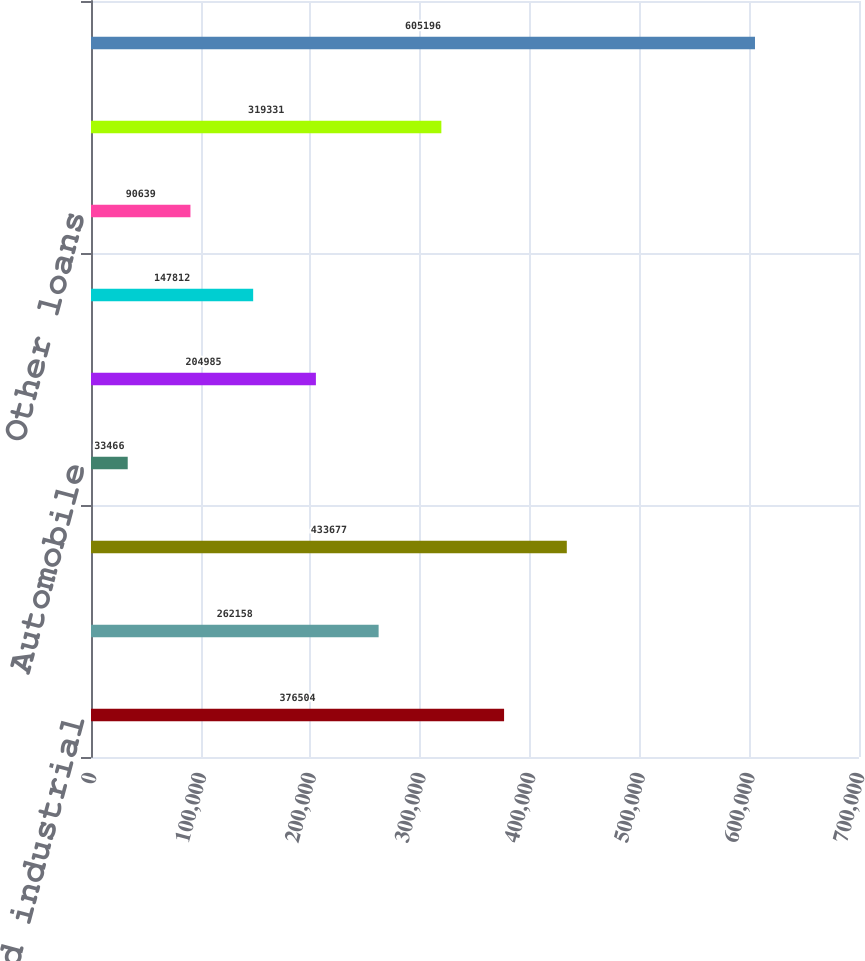Convert chart. <chart><loc_0><loc_0><loc_500><loc_500><bar_chart><fcel>Commercial and industrial<fcel>Commercial real estate<fcel>Total commercial<fcel>Automobile<fcel>Home equity<fcel>Residential mortgage<fcel>Other loans<fcel>Total consumer<fcel>Total allowance for loan and<nl><fcel>376504<fcel>262158<fcel>433677<fcel>33466<fcel>204985<fcel>147812<fcel>90639<fcel>319331<fcel>605196<nl></chart> 